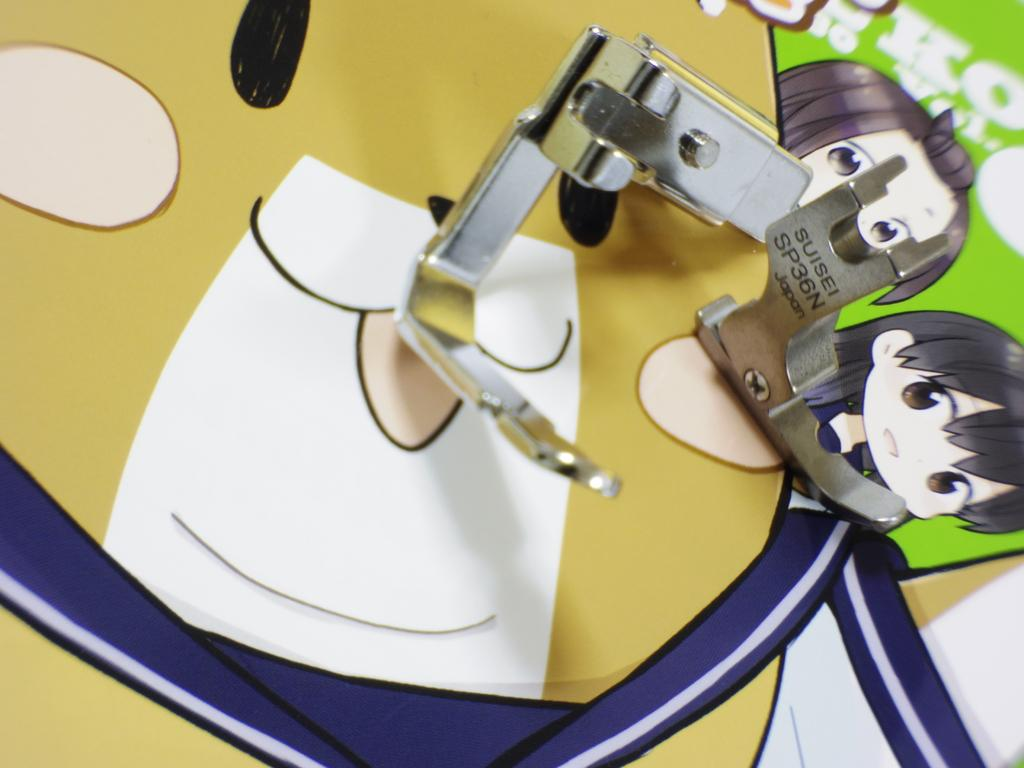What type of images can be seen in the picture? There are pictures of cartoon characters in the image. What is the color or material of the objects in the image? There are silver-colored objects in the image. Is there any text or writing in the image? Yes, there is something written in the image. What type of rock can be seen in the image? There is no rock present in the image. What kind of paste is being used to create the silver-colored objects in the image? There is no paste mentioned or visible in the image; the silver-colored objects are already formed. 